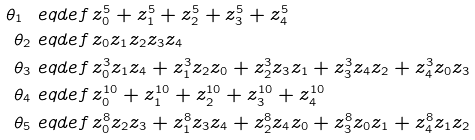<formula> <loc_0><loc_0><loc_500><loc_500>\theta _ { 1 } \ e q d e f & \, z _ { 0 } ^ { 5 } + z _ { 1 } ^ { 5 } + z _ { 2 } ^ { 5 } + z _ { 3 } ^ { 5 } + z _ { 4 } ^ { 5 } \\ \theta _ { 2 } \ e q d e f & \, z _ { 0 } z _ { 1 } z _ { 2 } z _ { 3 } z _ { 4 } \\ \theta _ { 3 } \ e q d e f & \, z _ { 0 } ^ { 3 } z _ { 1 } z _ { 4 } + z _ { 1 } ^ { 3 } z _ { 2 } z _ { 0 } + z _ { 2 } ^ { 3 } z _ { 3 } z _ { 1 } + z _ { 3 } ^ { 3 } z _ { 4 } z _ { 2 } + z _ { 4 } ^ { 3 } z _ { 0 } z _ { 3 } \\ \theta _ { 4 } \ e q d e f & \, z _ { 0 } ^ { 1 0 } + z _ { 1 } ^ { 1 0 } + z _ { 2 } ^ { 1 0 } + z _ { 3 } ^ { 1 0 } + z _ { 4 } ^ { 1 0 } \\ \theta _ { 5 } \ e q d e f & \, z _ { 0 } ^ { 8 } z _ { 2 } z _ { 3 } + z _ { 1 } ^ { 8 } z _ { 3 } z _ { 4 } + z _ { 2 } ^ { 8 } z _ { 4 } z _ { 0 } + z _ { 3 } ^ { 8 } z _ { 0 } z _ { 1 } + z _ { 4 } ^ { 8 } z _ { 1 } z _ { 2 }</formula> 